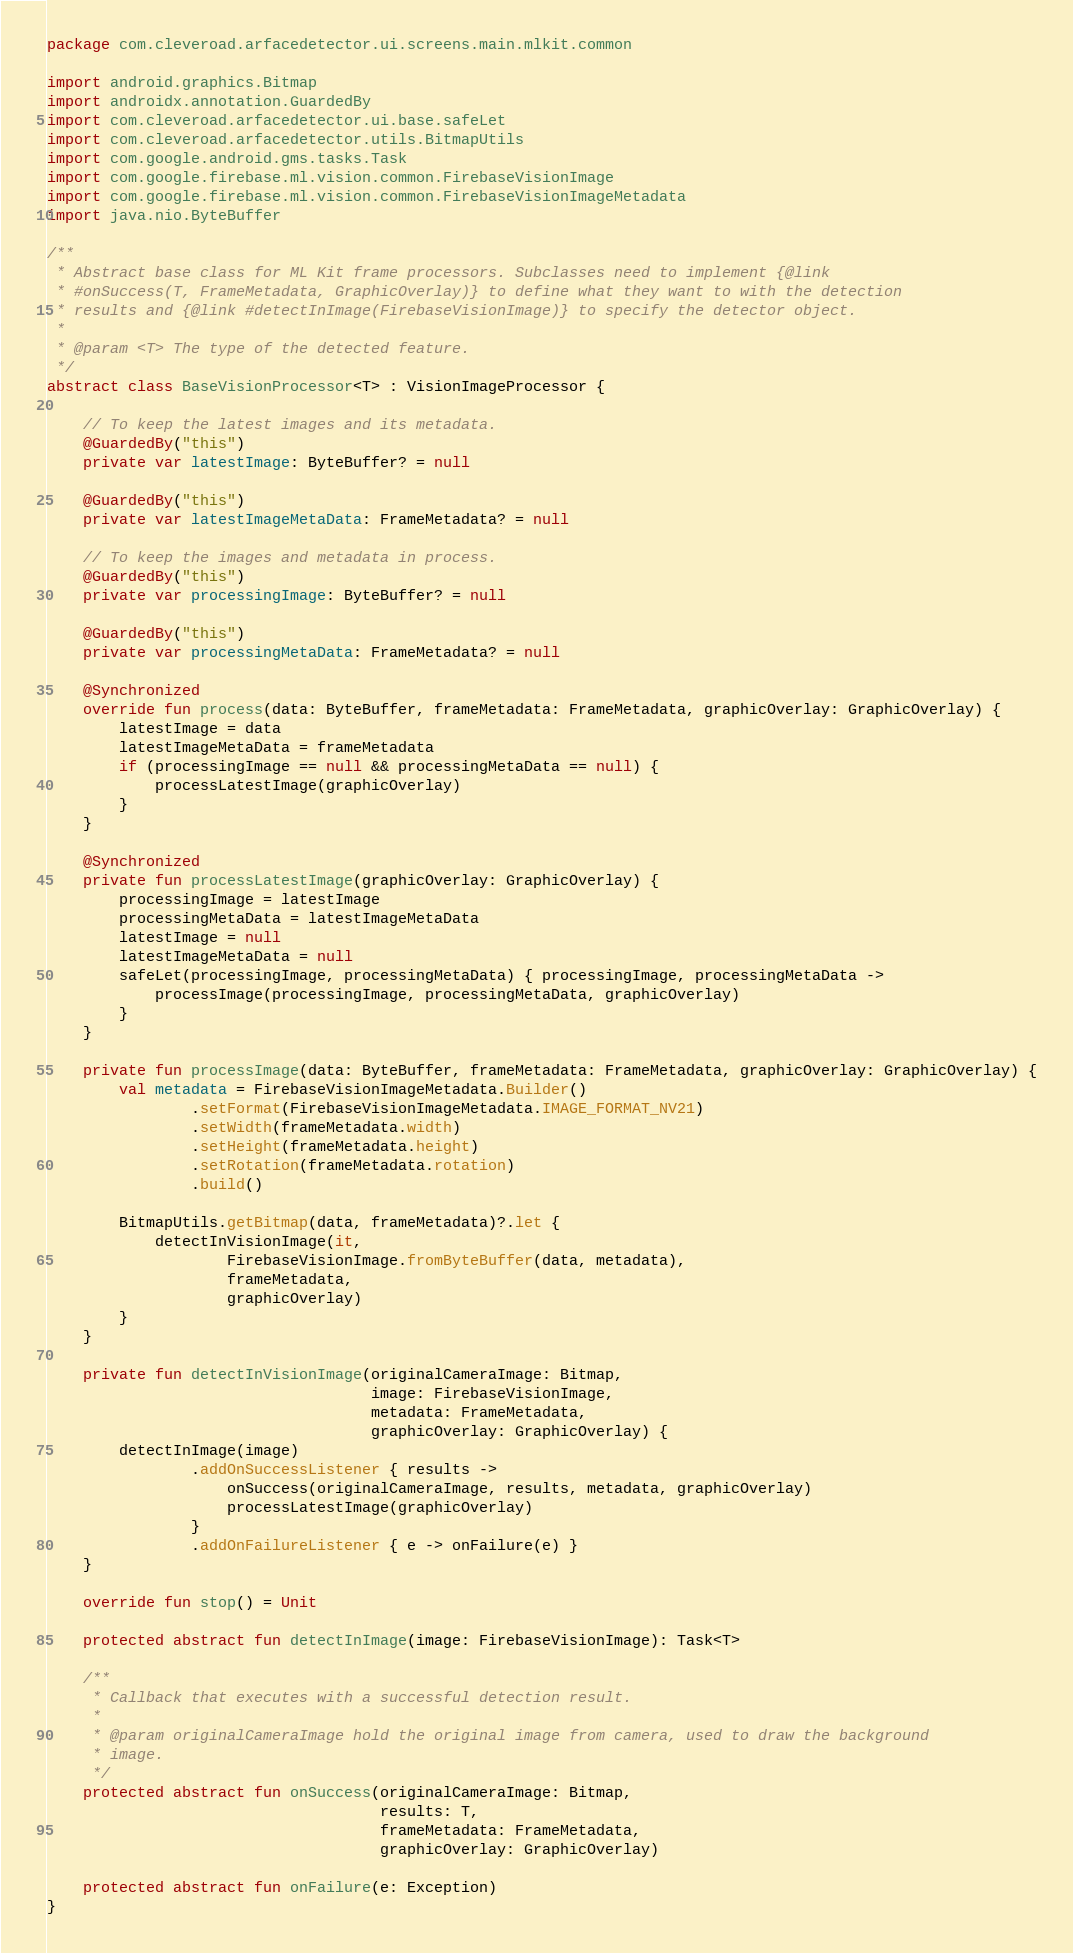<code> <loc_0><loc_0><loc_500><loc_500><_Kotlin_>package com.cleveroad.arfacedetector.ui.screens.main.mlkit.common

import android.graphics.Bitmap
import androidx.annotation.GuardedBy
import com.cleveroad.arfacedetector.ui.base.safeLet
import com.cleveroad.arfacedetector.utils.BitmapUtils
import com.google.android.gms.tasks.Task
import com.google.firebase.ml.vision.common.FirebaseVisionImage
import com.google.firebase.ml.vision.common.FirebaseVisionImageMetadata
import java.nio.ByteBuffer

/**
 * Abstract base class for ML Kit frame processors. Subclasses need to implement {@link
 * #onSuccess(T, FrameMetadata, GraphicOverlay)} to define what they want to with the detection
 * results and {@link #detectInImage(FirebaseVisionImage)} to specify the detector object.
 *
 * @param <T> The type of the detected feature.
 */
abstract class BaseVisionProcessor<T> : VisionImageProcessor {

    // To keep the latest images and its metadata.
    @GuardedBy("this")
    private var latestImage: ByteBuffer? = null

    @GuardedBy("this")
    private var latestImageMetaData: FrameMetadata? = null

    // To keep the images and metadata in process.
    @GuardedBy("this")
    private var processingImage: ByteBuffer? = null

    @GuardedBy("this")
    private var processingMetaData: FrameMetadata? = null

    @Synchronized
    override fun process(data: ByteBuffer, frameMetadata: FrameMetadata, graphicOverlay: GraphicOverlay) {
        latestImage = data
        latestImageMetaData = frameMetadata
        if (processingImage == null && processingMetaData == null) {
            processLatestImage(graphicOverlay)
        }
    }

    @Synchronized
    private fun processLatestImage(graphicOverlay: GraphicOverlay) {
        processingImage = latestImage
        processingMetaData = latestImageMetaData
        latestImage = null
        latestImageMetaData = null
        safeLet(processingImage, processingMetaData) { processingImage, processingMetaData ->
            processImage(processingImage, processingMetaData, graphicOverlay)
        }
    }

    private fun processImage(data: ByteBuffer, frameMetadata: FrameMetadata, graphicOverlay: GraphicOverlay) {
        val metadata = FirebaseVisionImageMetadata.Builder()
                .setFormat(FirebaseVisionImageMetadata.IMAGE_FORMAT_NV21)
                .setWidth(frameMetadata.width)
                .setHeight(frameMetadata.height)
                .setRotation(frameMetadata.rotation)
                .build()

        BitmapUtils.getBitmap(data, frameMetadata)?.let {
            detectInVisionImage(it,
                    FirebaseVisionImage.fromByteBuffer(data, metadata),
                    frameMetadata,
                    graphicOverlay)
        }
    }

    private fun detectInVisionImage(originalCameraImage: Bitmap,
                                    image: FirebaseVisionImage,
                                    metadata: FrameMetadata,
                                    graphicOverlay: GraphicOverlay) {
        detectInImage(image)
                .addOnSuccessListener { results ->
                    onSuccess(originalCameraImage, results, metadata, graphicOverlay)
                    processLatestImage(graphicOverlay)
                }
                .addOnFailureListener { e -> onFailure(e) }
    }

    override fun stop() = Unit

    protected abstract fun detectInImage(image: FirebaseVisionImage): Task<T>

    /**
     * Callback that executes with a successful detection result.
     *
     * @param originalCameraImage hold the original image from camera, used to draw the background
     * image.
     */
    protected abstract fun onSuccess(originalCameraImage: Bitmap,
                                     results: T,
                                     frameMetadata: FrameMetadata,
                                     graphicOverlay: GraphicOverlay)

    protected abstract fun onFailure(e: Exception)
}
</code> 